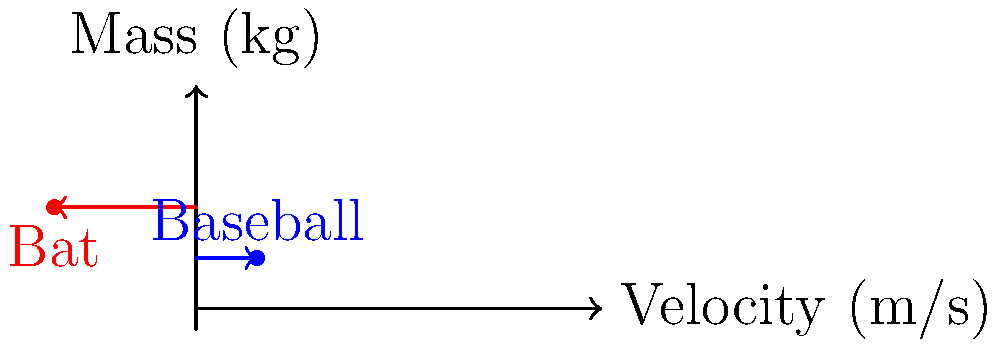As you consider signing up your child for baseball, you decide to brush up on some physics concepts related to the game. In a collision between a baseball bat and a ball, the baseball (mass 0.5 kg) approaches the bat at 30 m/s, while the bat (mass 1 kg) is swung at -70 m/s (negative indicating opposite direction). Assuming a perfectly elastic collision, what is the change in momentum of the baseball? Let's approach this step-by-step:

1) First, recall that momentum is given by the formula $p = mv$, where $m$ is mass and $v$ is velocity.

2) The initial momentum of the baseball:
   $p_{1i} = m_1v_{1i} = (0.5 \text{ kg})(30 \text{ m/s}) = 15 \text{ kg⋅m/s}$

3) For a perfectly elastic collision, we can use the principle of conservation of momentum:
   $m_1v_{1i} + m_2v_{2i} = m_1v_{1f} + m_2v_{2f}$

4) We also know that in a perfectly elastic collision, the relative velocity of separation equals the relative velocity of approach:
   $v_{1i} - v_{2i} = -(v_{1f} - v_{2f})$

5) From these equations, we can derive (after some algebra) that the final velocity of the baseball is:
   $v_{1f} = \frac{(m_1 - m_2)v_{1i} + 2m_2v_{2i}}{m_1 + m_2}$

6) Plugging in our values:
   $v_{1f} = \frac{(0.5 - 1)(30) + 2(1)(-70)}{0.5 + 1} = -110 \text{ m/s}$

7) Now we can calculate the final momentum of the baseball:
   $p_{1f} = m_1v_{1f} = (0.5 \text{ kg})(-110 \text{ m/s}) = -55 \text{ kg⋅m/s}$

8) The change in momentum is the final momentum minus the initial momentum:
   $\Delta p = p_{1f} - p_{1i} = -55 - 15 = -70 \text{ kg⋅m/s}$

The negative sign indicates that the momentum changed direction.
Answer: $-70 \text{ kg⋅m/s}$ 